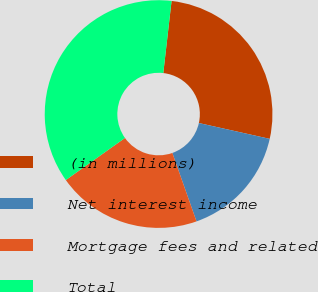Convert chart to OTSL. <chart><loc_0><loc_0><loc_500><loc_500><pie_chart><fcel>(in millions)<fcel>Net interest income<fcel>Mortgage fees and related<fcel>Total<nl><fcel>26.68%<fcel>16.1%<fcel>20.56%<fcel>36.66%<nl></chart> 